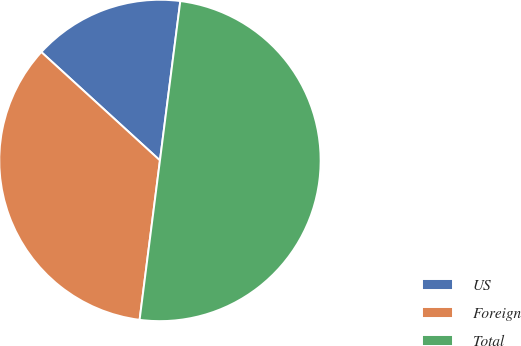Convert chart to OTSL. <chart><loc_0><loc_0><loc_500><loc_500><pie_chart><fcel>US<fcel>Foreign<fcel>Total<nl><fcel>15.24%<fcel>34.76%<fcel>50.0%<nl></chart> 